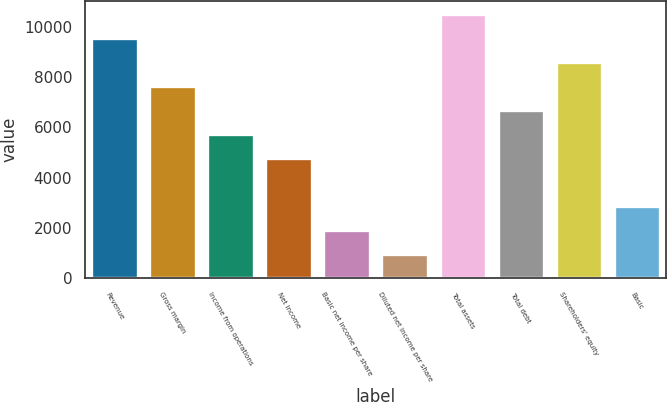<chart> <loc_0><loc_0><loc_500><loc_500><bar_chart><fcel>Revenue<fcel>Gross margin<fcel>Income from operations<fcel>Net income<fcel>Basic net income per share<fcel>Diluted net income per share<fcel>Total assets<fcel>Total debt<fcel>Shareholders' equity<fcel>Basic<nl><fcel>9544.02<fcel>7635.28<fcel>5726.54<fcel>4772.17<fcel>1909.06<fcel>954.69<fcel>10498.4<fcel>6680.91<fcel>8589.65<fcel>2863.43<nl></chart> 